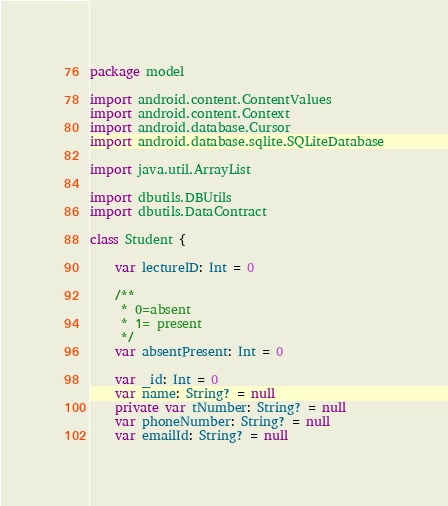Convert code to text. <code><loc_0><loc_0><loc_500><loc_500><_Kotlin_>package model

import android.content.ContentValues
import android.content.Context
import android.database.Cursor
import android.database.sqlite.SQLiteDatabase

import java.util.ArrayList

import dbutils.DBUtils
import dbutils.DataContract

class Student {

    var lectureID: Int = 0

    /**
     * 0=absent
     * 1= present
     */
    var absentPresent: Int = 0

    var _id: Int = 0
    var name: String? = null
    private var tNumber: String? = null
    var phoneNumber: String? = null
    var emailId: String? = null
</code> 